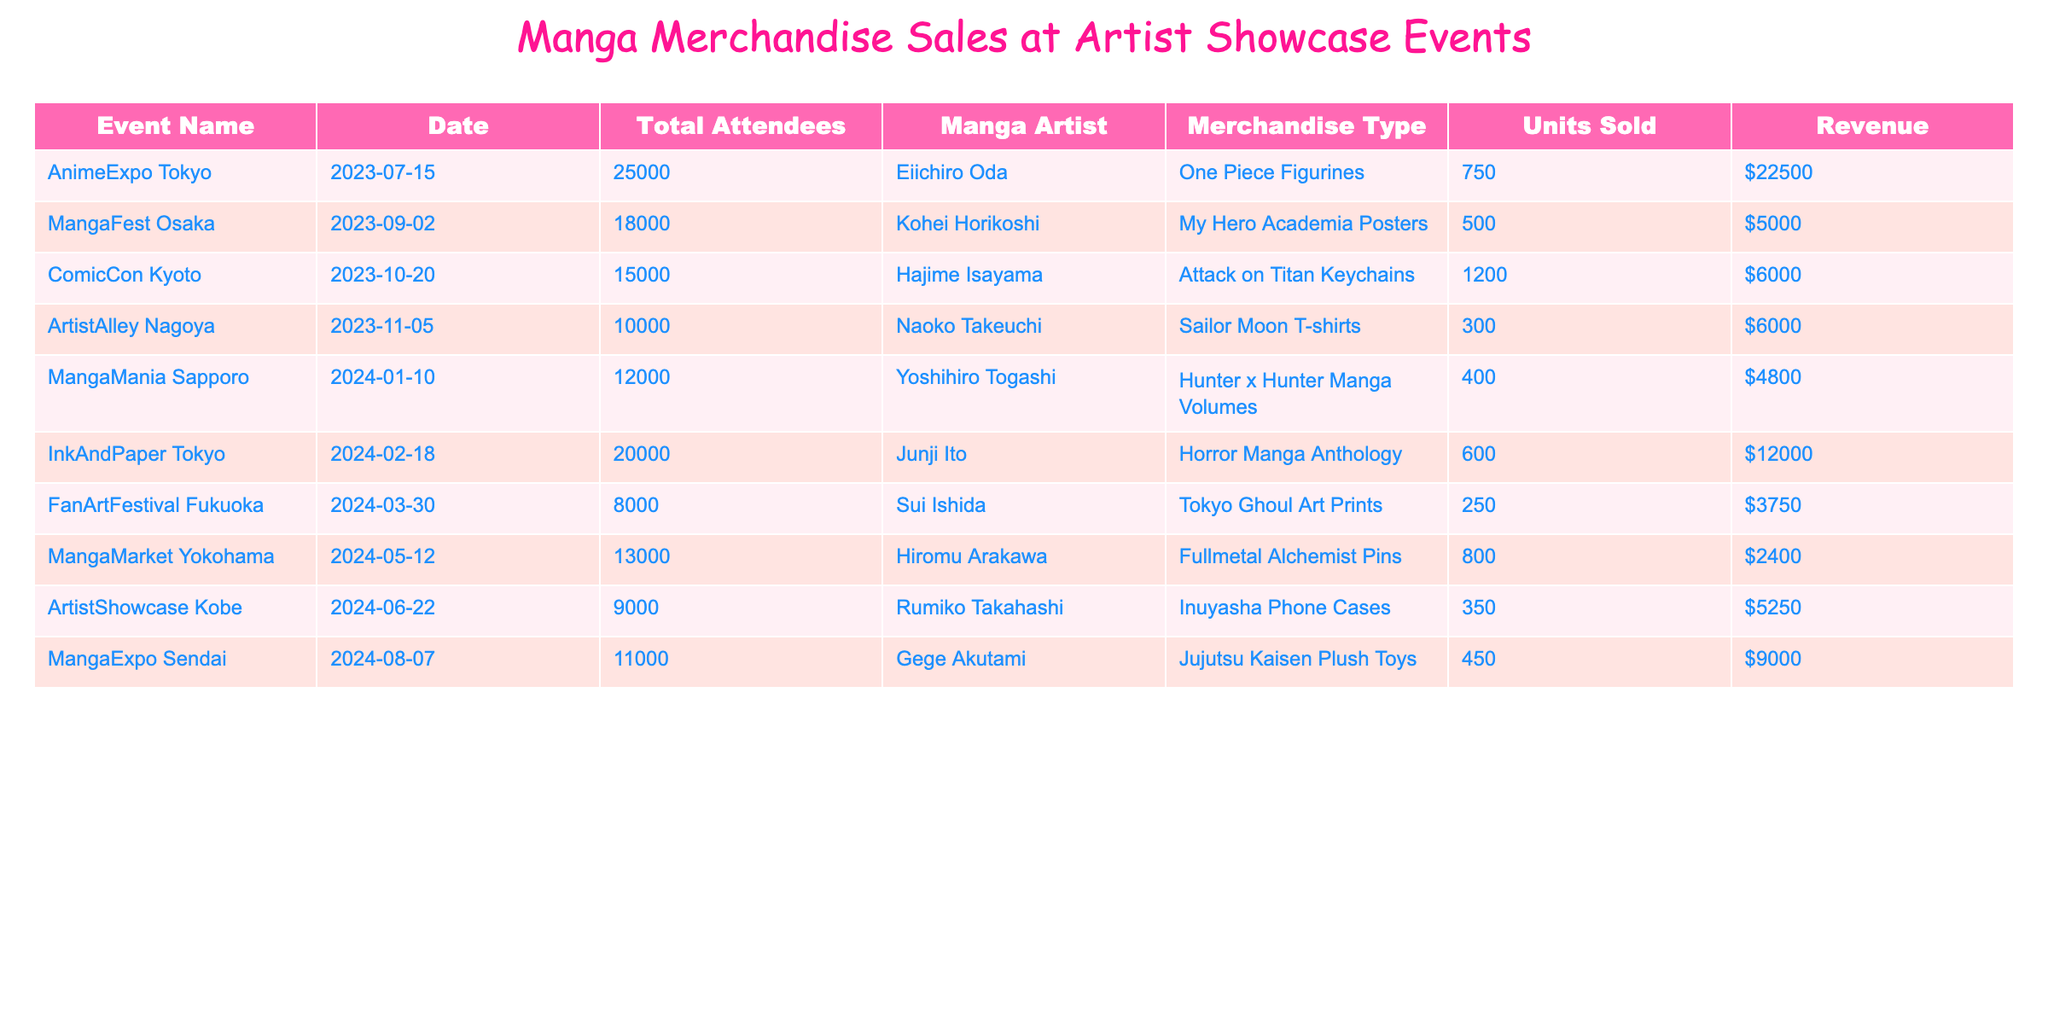What is the total revenue generated from the sales at the AnimeExpo Tokyo? The revenue generated from AnimeExpo Tokyo can be found in the table under the Revenue column for the event. The value listed is $22,500.
Answer: $22,500 How many units of merchandise were sold at the ComicCon Kyoto? The number of units sold at ComicCon Kyoto is provided in the table, which shows that 1,200 units of Attack on Titan Keychains were sold.
Answer: 1,200 Which manga artist sold the least amount of merchandise units? By comparing the Units Sold column, it can be determined that Hiromu Arakawa sold the least with 800 units of Fullmetal Alchemist Pins.
Answer: Hiromu Arakawa What was the average revenue per event based on the data presented? To find the average revenue, sum all revenues ($22,500 + $5,000 + $6,000 + $6,000 + $4,800 + $12,000 + $3,750 + $2,400 + $5,250 + $9,000 = $76,700) and divide by the number of events (10), giving an average of $7,670.
Answer: $7,670 Did Sui Ishida sell more units than Yoshihiro Togashi? By comparing the Units Sold for Sui Ishida (250 units) and Yoshihiro Togashi (400 units) in the table, it's clear that Sui Ishida sold fewer units.
Answer: No What event had the highest total attendance and what was the corresponding total revenue? The event with the highest attendance is AnimeExpo Tokyo with 25,000 attendees, which generated a total revenue of $22,500 as indicated in the table.
Answer: 25,000 attendees, $22,500 revenue Which merchandise type generated the highest revenue at the events? The revenue for each merchandise type can be compared, and One Piece Figurines generated the highest at $22,500, per the table.
Answer: One Piece Figurines How much total revenue was generated from merchandise sold by Kohei Horikoshi and Naoko Takeuchi combined? The revenue from Kohei Horikoshi ($5,000) and Naoko Takeuchi ($6,000) can be summed together (5,000 + 6,000 = $11,000).
Answer: $11,000 For which event did the least amount of revenue get generated, and what was that revenue? By reviewing the Revenue column, MangaMarket Yokohama generated the least with revenue listed as $2,400.
Answer: MangaMarket Yokohama, $2,400 Are there any events where the revenue exceeded $10,000? By checking the revenue figures in the table, it's clear that AnimeExpo Tokyo ($22,500) and InkAndPaper Tokyo ($12,000) both exceeded $10,000.
Answer: Yes, two events 